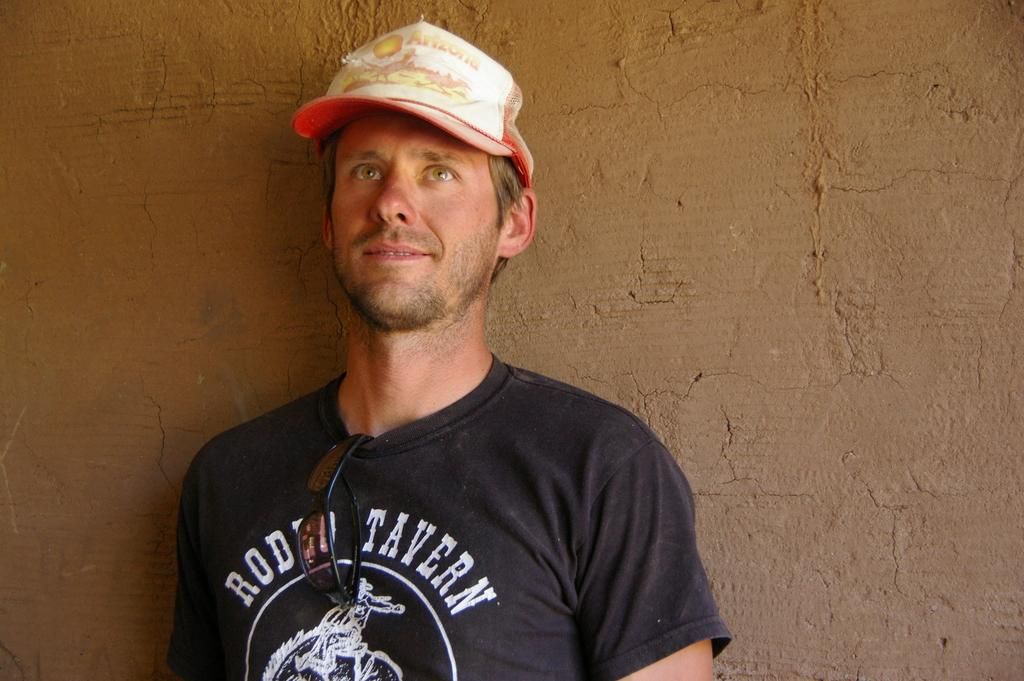Provide a one-sentence caption for the provided image. A man wears a black shirt that says RODEO TAVERN. 